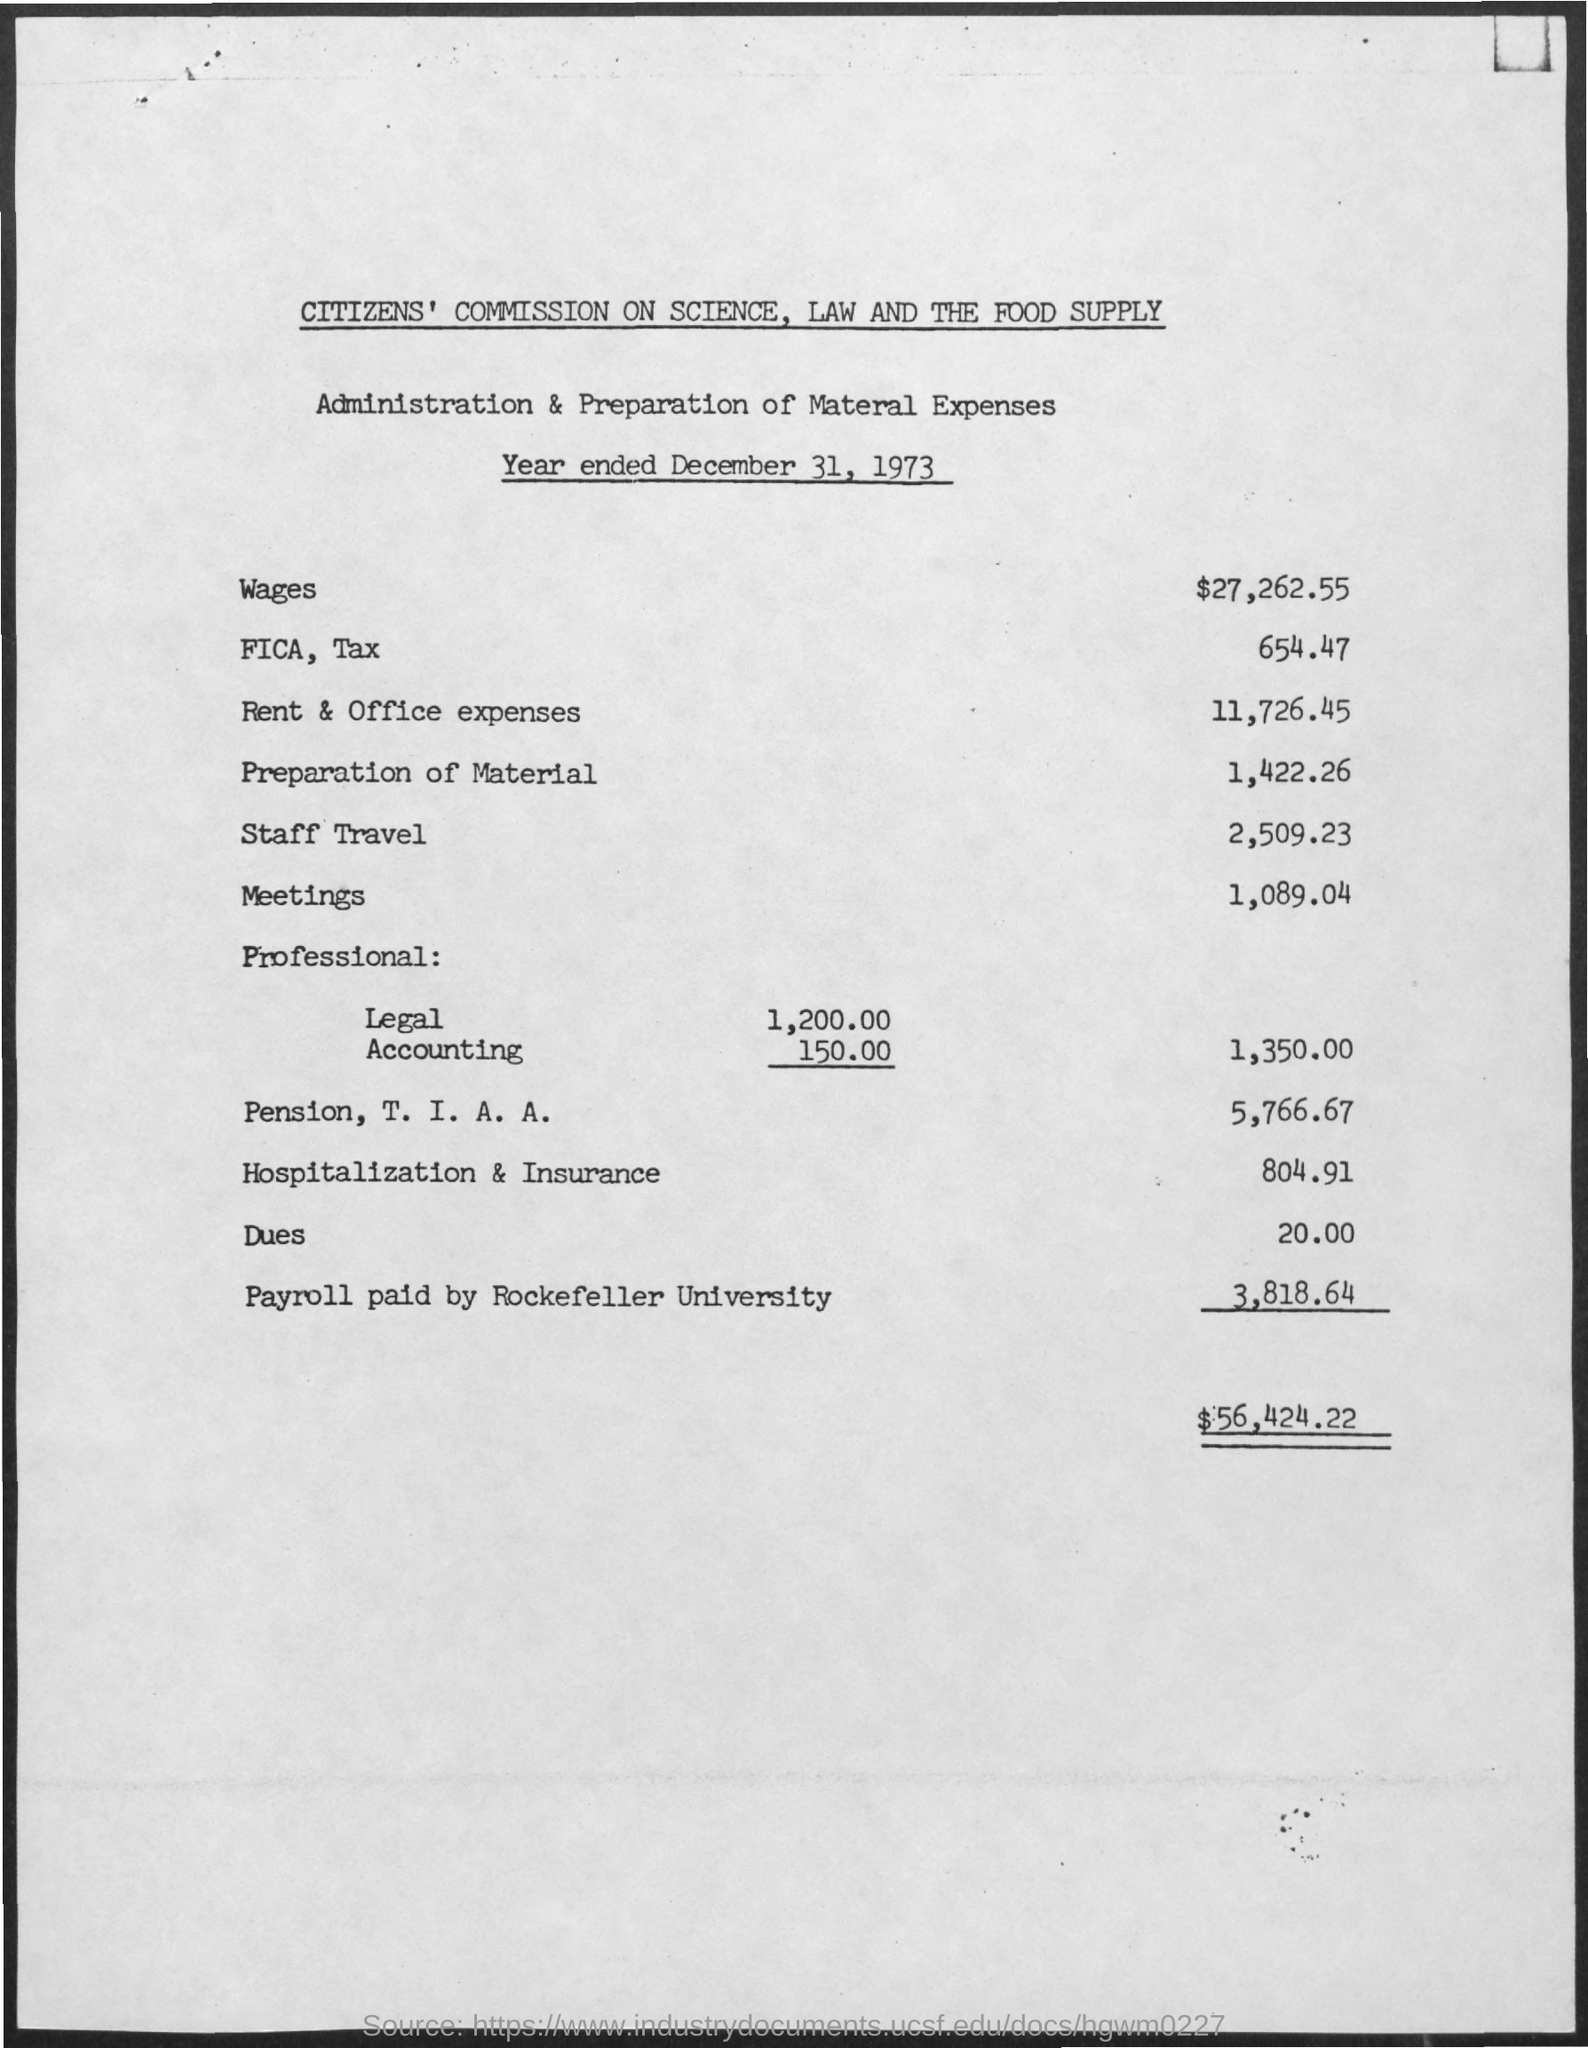Highlight a few significant elements in this photo. The expense incurred for the preparation of materials for the year ended December 31, 1973, was $1,422.26. The rent and office expenses for the year ended December 31, 1973, were $11,726.45. The staff's travel expenses for the year ended December 31, 1973, were 2,509.23. The payroll for the year ended December 31, 1973, at Rockefeller University was $3,818.64. The wages for the year ended December 31, 1973, were $27,262.55. 